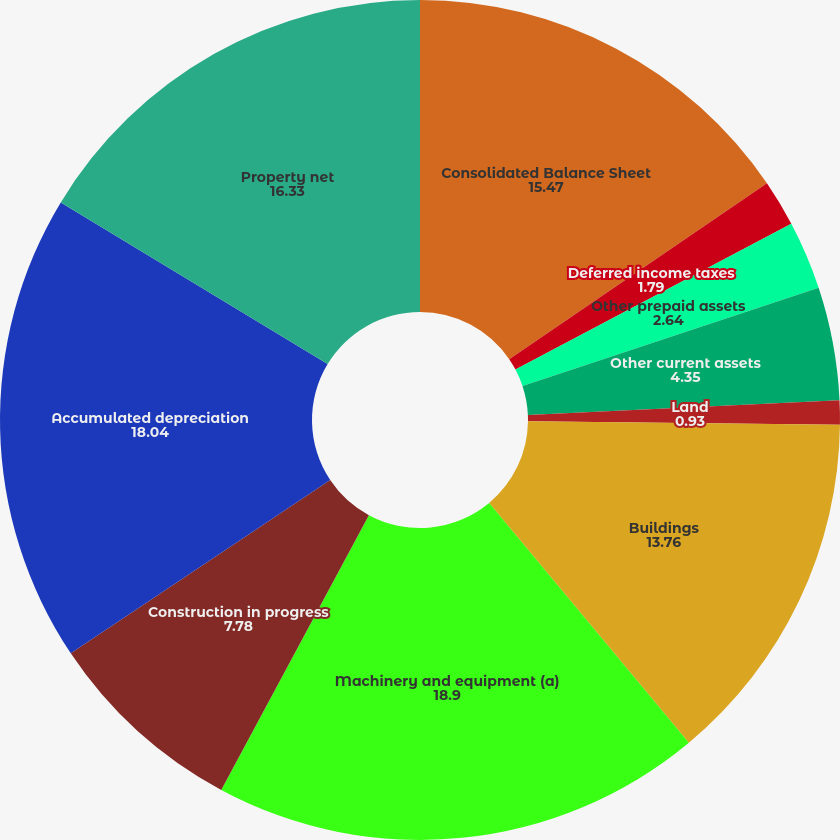Convert chart. <chart><loc_0><loc_0><loc_500><loc_500><pie_chart><fcel>Consolidated Balance Sheet<fcel>Deferred income taxes<fcel>Other prepaid assets<fcel>Other current assets<fcel>Land<fcel>Buildings<fcel>Machinery and equipment (a)<fcel>Construction in progress<fcel>Accumulated depreciation<fcel>Property net<nl><fcel>15.47%<fcel>1.79%<fcel>2.64%<fcel>4.35%<fcel>0.93%<fcel>13.76%<fcel>18.9%<fcel>7.78%<fcel>18.04%<fcel>16.33%<nl></chart> 